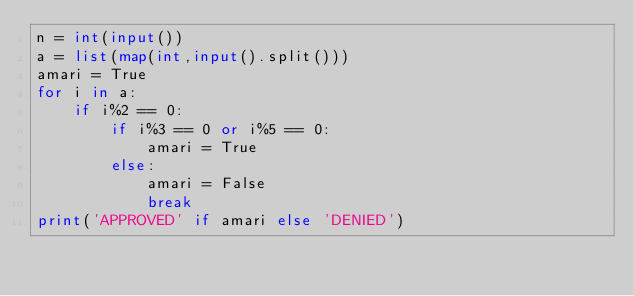Convert code to text. <code><loc_0><loc_0><loc_500><loc_500><_Python_>n = int(input())
a = list(map(int,input().split()))
amari = True
for i in a:
    if i%2 == 0:
        if i%3 == 0 or i%5 == 0:
            amari = True
        else:
            amari = False
            break
print('APPROVED' if amari else 'DENIED')</code> 